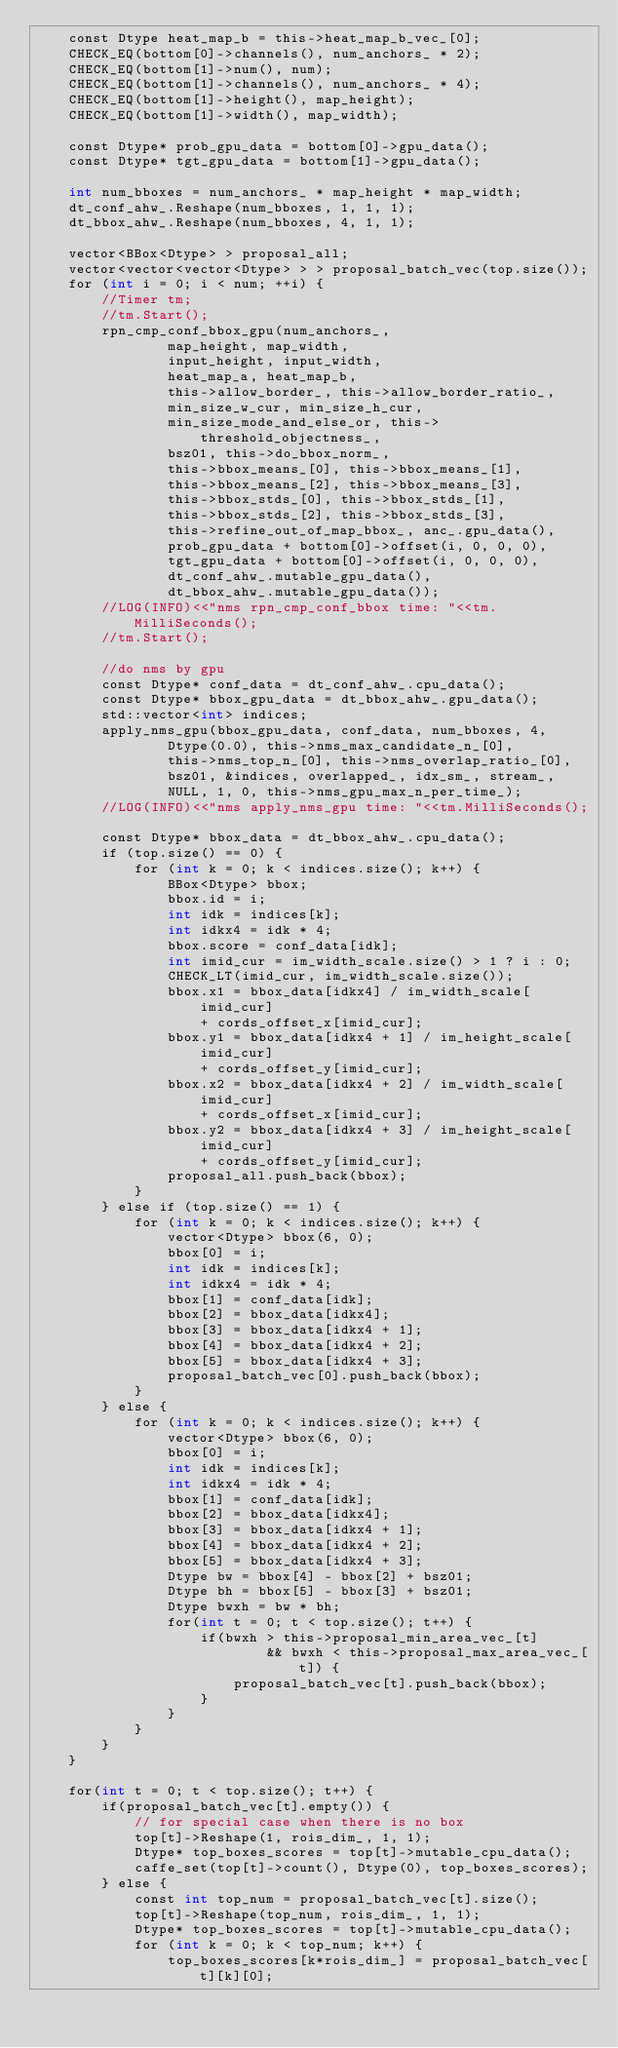Convert code to text. <code><loc_0><loc_0><loc_500><loc_500><_Cuda_>    const Dtype heat_map_b = this->heat_map_b_vec_[0];
    CHECK_EQ(bottom[0]->channels(), num_anchors_ * 2);
    CHECK_EQ(bottom[1]->num(), num);
    CHECK_EQ(bottom[1]->channels(), num_anchors_ * 4);
    CHECK_EQ(bottom[1]->height(), map_height);
    CHECK_EQ(bottom[1]->width(), map_width);

    const Dtype* prob_gpu_data = bottom[0]->gpu_data();
    const Dtype* tgt_gpu_data = bottom[1]->gpu_data();

    int num_bboxes = num_anchors_ * map_height * map_width;
    dt_conf_ahw_.Reshape(num_bboxes, 1, 1, 1);
    dt_bbox_ahw_.Reshape(num_bboxes, 4, 1, 1);

    vector<BBox<Dtype> > proposal_all;
    vector<vector<vector<Dtype> > > proposal_batch_vec(top.size());
    for (int i = 0; i < num; ++i) {
        //Timer tm;
        //tm.Start();
        rpn_cmp_conf_bbox_gpu(num_anchors_,
                map_height, map_width,
                input_height, input_width,
                heat_map_a, heat_map_b,
                this->allow_border_, this->allow_border_ratio_,
                min_size_w_cur, min_size_h_cur,
                min_size_mode_and_else_or, this->threshold_objectness_,
                bsz01, this->do_bbox_norm_,
                this->bbox_means_[0], this->bbox_means_[1],
                this->bbox_means_[2], this->bbox_means_[3],
                this->bbox_stds_[0], this->bbox_stds_[1],
                this->bbox_stds_[2], this->bbox_stds_[3],
                this->refine_out_of_map_bbox_, anc_.gpu_data(), 
                prob_gpu_data + bottom[0]->offset(i, 0, 0, 0), 
                tgt_gpu_data + bottom[0]->offset(i, 0, 0, 0), 
                dt_conf_ahw_.mutable_gpu_data(),
                dt_bbox_ahw_.mutable_gpu_data());
        //LOG(INFO)<<"nms rpn_cmp_conf_bbox time: "<<tm.MilliSeconds();
        //tm.Start();

        //do nms by gpu
        const Dtype* conf_data = dt_conf_ahw_.cpu_data();
        const Dtype* bbox_gpu_data = dt_bbox_ahw_.gpu_data();
        std::vector<int> indices;
        apply_nms_gpu(bbox_gpu_data, conf_data, num_bboxes, 4,
                Dtype(0.0), this->nms_max_candidate_n_[0], 
                this->nms_top_n_[0], this->nms_overlap_ratio_[0], 
                bsz01, &indices, overlapped_, idx_sm_, stream_,
                NULL, 1, 0, this->nms_gpu_max_n_per_time_);
        //LOG(INFO)<<"nms apply_nms_gpu time: "<<tm.MilliSeconds();

        const Dtype* bbox_data = dt_bbox_ahw_.cpu_data();
        if (top.size() == 0) {
            for (int k = 0; k < indices.size(); k++) {
                BBox<Dtype> bbox;
                bbox.id = i;
                int idk = indices[k];
                int idkx4 = idk * 4;
                bbox.score = conf_data[idk];
                int imid_cur = im_width_scale.size() > 1 ? i : 0;
                CHECK_LT(imid_cur, im_width_scale.size());
                bbox.x1 = bbox_data[idkx4] / im_width_scale[imid_cur] 
                    + cords_offset_x[imid_cur];
                bbox.y1 = bbox_data[idkx4 + 1] / im_height_scale[imid_cur] 
                    + cords_offset_y[imid_cur]; 
                bbox.x2 = bbox_data[idkx4 + 2] / im_width_scale[imid_cur] 
                    + cords_offset_x[imid_cur]; 
                bbox.y2 = bbox_data[idkx4 + 3] / im_height_scale[imid_cur] 
                    + cords_offset_y[imid_cur]; 
                proposal_all.push_back(bbox);
            }
        } else if (top.size() == 1) {
            for (int k = 0; k < indices.size(); k++) {
                vector<Dtype> bbox(6, 0);
                bbox[0] = i;
                int idk = indices[k];
                int idkx4 = idk * 4;
                bbox[1] = conf_data[idk];
                bbox[2] = bbox_data[idkx4];
                bbox[3] = bbox_data[idkx4 + 1];
                bbox[4] = bbox_data[idkx4 + 2];
                bbox[5] = bbox_data[idkx4 + 3];
                proposal_batch_vec[0].push_back(bbox);
            }
        } else {
            for (int k = 0; k < indices.size(); k++) {
                vector<Dtype> bbox(6, 0);
                bbox[0] = i;
                int idk = indices[k];
                int idkx4 = idk * 4;
                bbox[1] = conf_data[idk];
                bbox[2] = bbox_data[idkx4];
                bbox[3] = bbox_data[idkx4 + 1];
                bbox[4] = bbox_data[idkx4 + 2];
                bbox[5] = bbox_data[idkx4 + 3];
                Dtype bw = bbox[4] - bbox[2] + bsz01; 
                Dtype bh = bbox[5] - bbox[3] + bsz01; 
                Dtype bwxh = bw * bh;
                for(int t = 0; t < top.size(); t++) {
                    if(bwxh > this->proposal_min_area_vec_[t] 
                            && bwxh < this->proposal_max_area_vec_[t]) {
                        proposal_batch_vec[t].push_back(bbox);
                    }
                }
            }
        }
    }

    for(int t = 0; t < top.size(); t++) {
        if(proposal_batch_vec[t].empty()) {
            // for special case when there is no box
            top[t]->Reshape(1, rois_dim_, 1, 1);
            Dtype* top_boxes_scores = top[t]->mutable_cpu_data();
            caffe_set(top[t]->count(), Dtype(0), top_boxes_scores); 
        } else {
            const int top_num = proposal_batch_vec[t].size();
            top[t]->Reshape(top_num, rois_dim_, 1, 1);
            Dtype* top_boxes_scores = top[t]->mutable_cpu_data();
            for (int k = 0; k < top_num; k++) {
                top_boxes_scores[k*rois_dim_] = proposal_batch_vec[t][k][0];</code> 